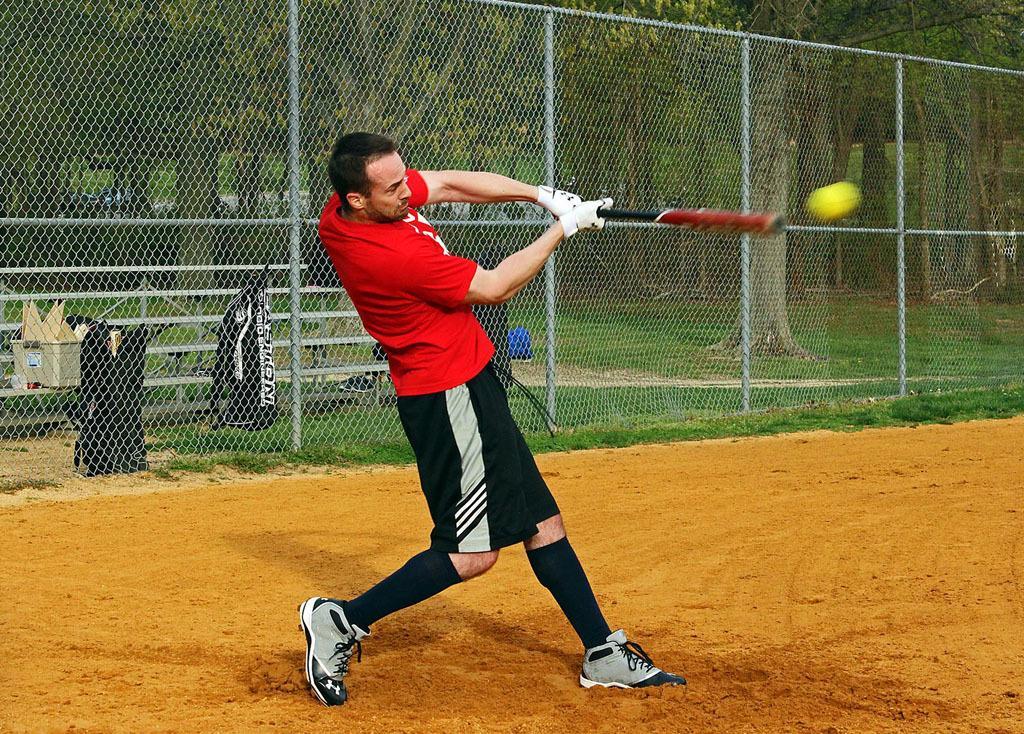Could you give a brief overview of what you see in this image? In this image there is a man playing hockey in the ground, behind him there is a fence and beyond that there are some garbage bags and trees at the back. 